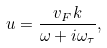<formula> <loc_0><loc_0><loc_500><loc_500>u = \frac { v _ { F } k } { \omega + i \omega _ { \tau } } ,</formula> 